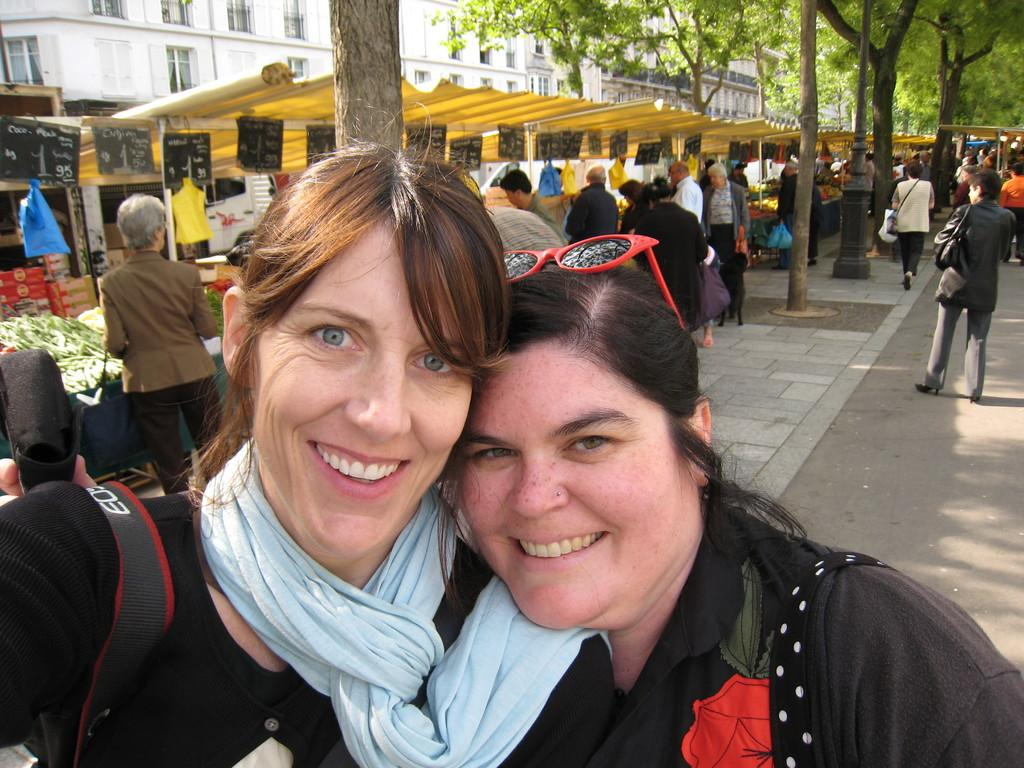How many people are smiling in the image? There are two persons smiling in the image. What objects can be seen in the image besides the people? There are boards, trees, stalls, and buildings visible in the image. Can you describe the group of people in the image? There is a group of people standing in the image. What is visible in the background of the image? There are buildings visible in the background of the image. What type of balls are being used by the writer in the image? There is no writer or balls present in the image. 